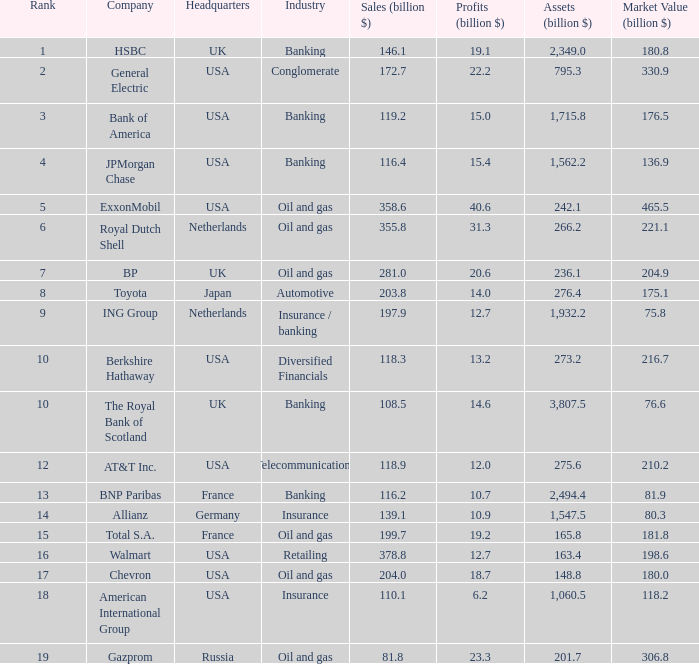What is the maximum level of a corporation possessing 1,71 3.0. 